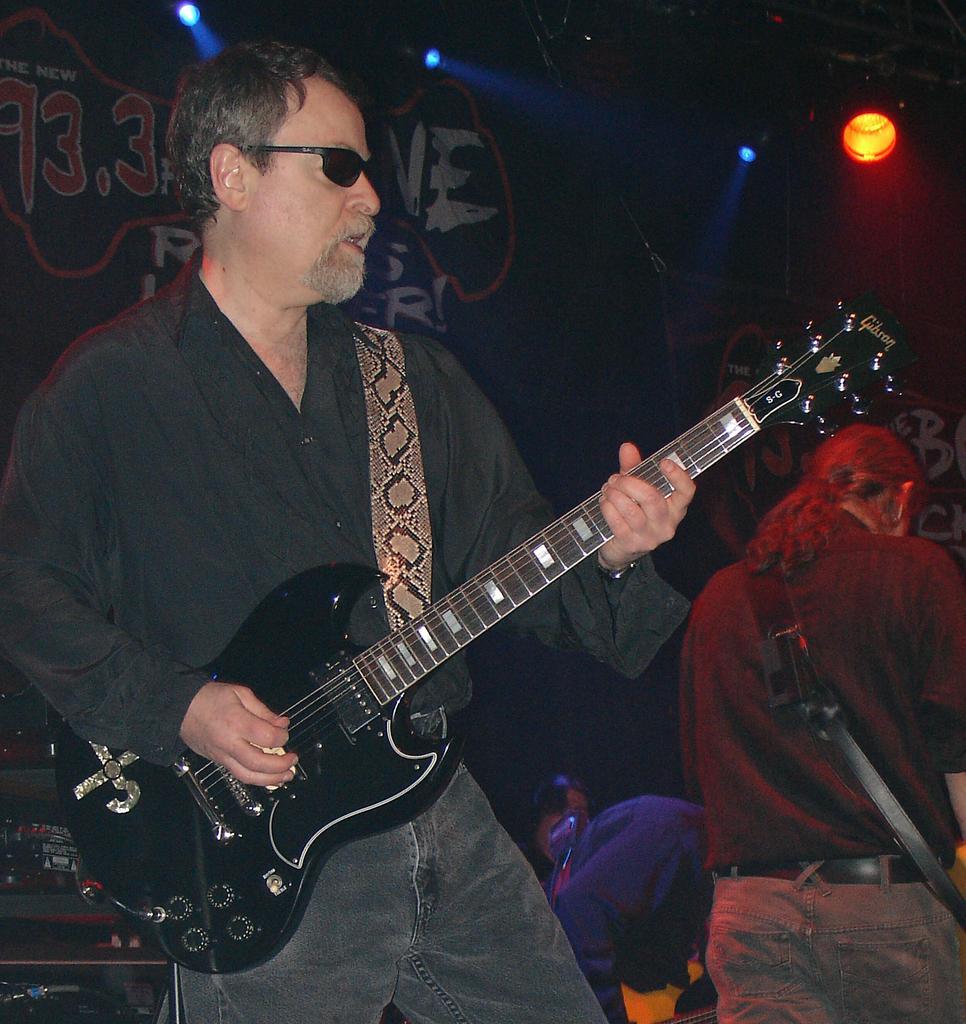In one or two sentences, can you explain what this image depicts? In this image there is a man standing and playing a guitar , at the background there is another person standing , focus light, banner. 